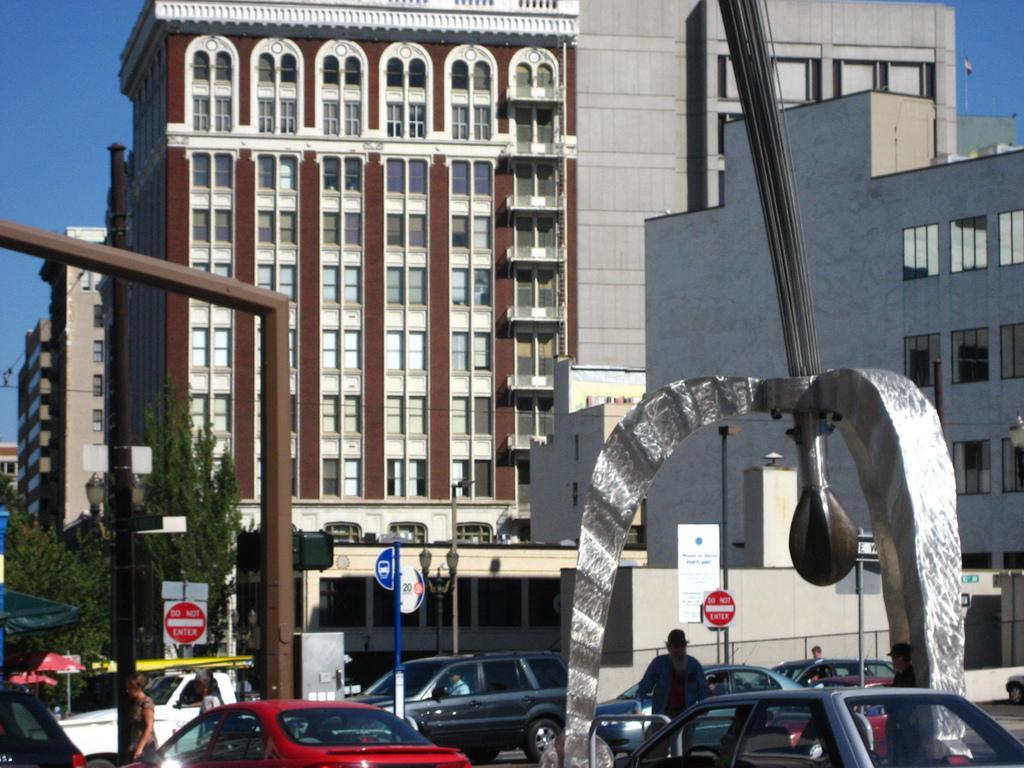Describe this image in one or two sentences. In the image we can see there are buildings and cars are parked on the road and people are standing on the road. 